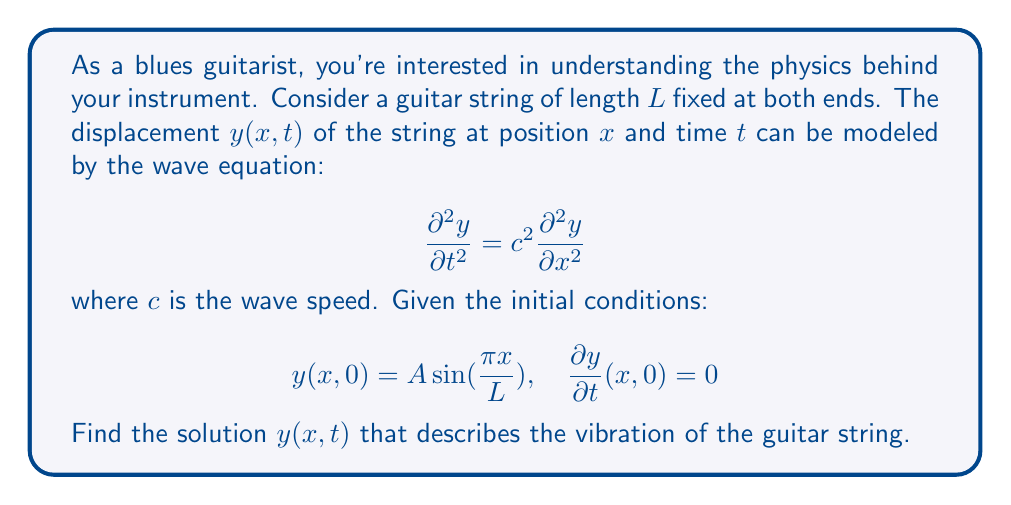Could you help me with this problem? To solve this problem, we'll use the method of separation of variables:

1) Assume the solution has the form $y(x,t) = X(x)T(t)$.

2) Substitute this into the wave equation:
   $$X(x)T''(t) = c^2X''(x)T(t)$$

3) Divide both sides by $X(x)T(t)$:
   $$\frac{T''(t)}{T(t)} = c^2\frac{X''(x)}{X(x)} = -\lambda$$
   where $\lambda$ is a constant.

4) This gives us two ordinary differential equations:
   $$T''(t) + \lambda c^2T(t) = 0$$
   $$X''(x) + \lambda X(x) = 0$$

5) The boundary conditions $y(0,t) = y(L,t) = 0$ imply $X(0) = X(L) = 0$.
   This gives the eigenvalue $\lambda = (\frac{n\pi}{L})^2$ and eigenfunction $X_n(x) = \sin(\frac{n\pi x}{L})$.

6) The general solution for $T(t)$ is:
   $$T_n(t) = A_n \cos(\frac{n\pi c}{L}t) + B_n \sin(\frac{n\pi c}{L}t)$$

7) The general solution for $y(x,t)$ is:
   $$y(x,t) = \sum_{n=1}^{\infty} [A_n \cos(\frac{n\pi c}{L}t) + B_n \sin(\frac{n\pi c}{L}t)] \sin(\frac{n\pi x}{L})$$

8) Apply the initial conditions:
   $y(x,0) = A \sin(\frac{\pi x}{L})$ implies $A_1 = A$ and $A_n = 0$ for $n > 1$.
   $\frac{\partial y}{\partial t}(x,0) = 0$ implies $B_n = 0$ for all $n$.

9) Therefore, the final solution is:
   $$y(x,t) = A \cos(\frac{\pi c}{L}t) \sin(\frac{\pi x}{L})$$
Answer: $y(x,t) = A \cos(\frac{\pi c}{L}t) \sin(\frac{\pi x}{L})$ 